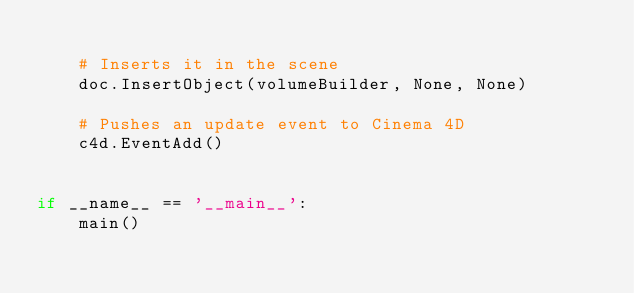<code> <loc_0><loc_0><loc_500><loc_500><_Python_>
    # Inserts it in the scene
    doc.InsertObject(volumeBuilder, None, None)

    # Pushes an update event to Cinema 4D
    c4d.EventAdd()


if __name__ == '__main__':
    main()
</code> 